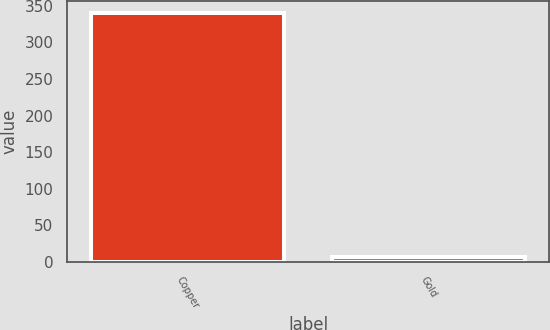<chart> <loc_0><loc_0><loc_500><loc_500><bar_chart><fcel>Copper<fcel>Gold<nl><fcel>340<fcel>7<nl></chart> 